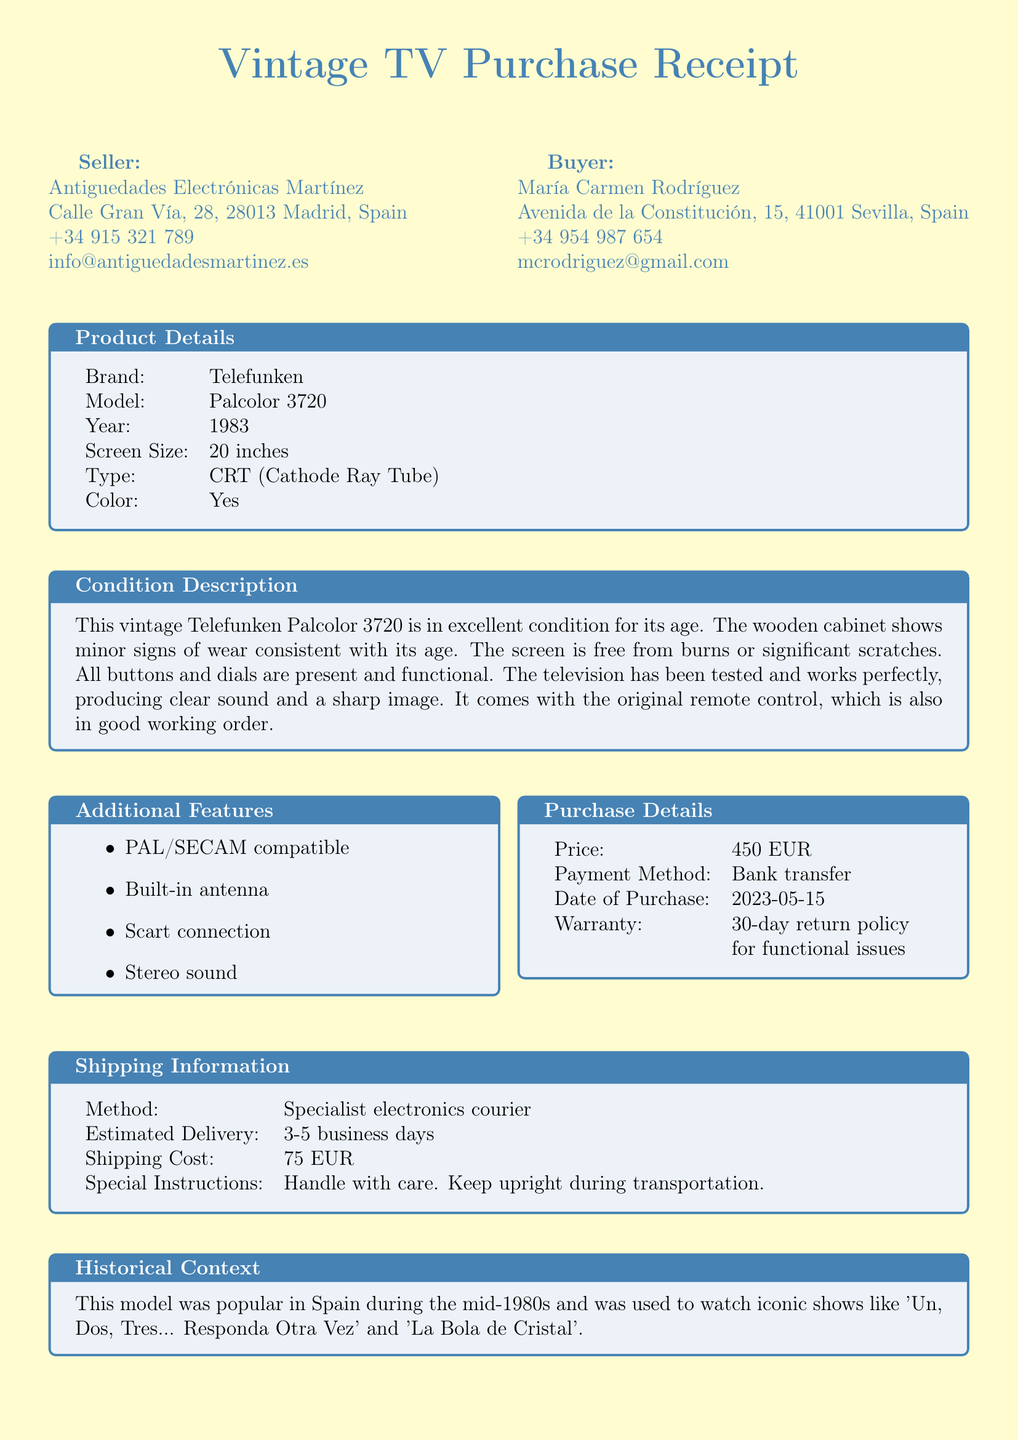What is the seller's name? The seller's name is mentioned in the seller information section of the document.
Answer: Antiguedades Electrónicas Martínez What is the model of the television? The model is specified in the product details section.
Answer: Palcolor 3720 What is the purchase date? The purchase date is outlined in the purchase details section.
Answer: 2023-05-15 What is the warranty period? The warranty period is mentioned in the purchase details section.
Answer: 30-day return policy What is the condition of the television? The condition of the television is described in the condition description section.
Answer: Excellent condition How much did the television cost? The cost is listed in the purchase details.
Answer: 450 EUR What is included with the television? The inclusion is mentioned in the condition description.
Answer: Original remote control Which shows were popular during the use of this model? The shows are referenced in the historical context section.
Answer: Un, Dos, Tres... Responda Otra Vez and La Bola de Cristal How is the item delivered? The delivery method is noted in the shipping information section.
Answer: Specialist electronics courier 